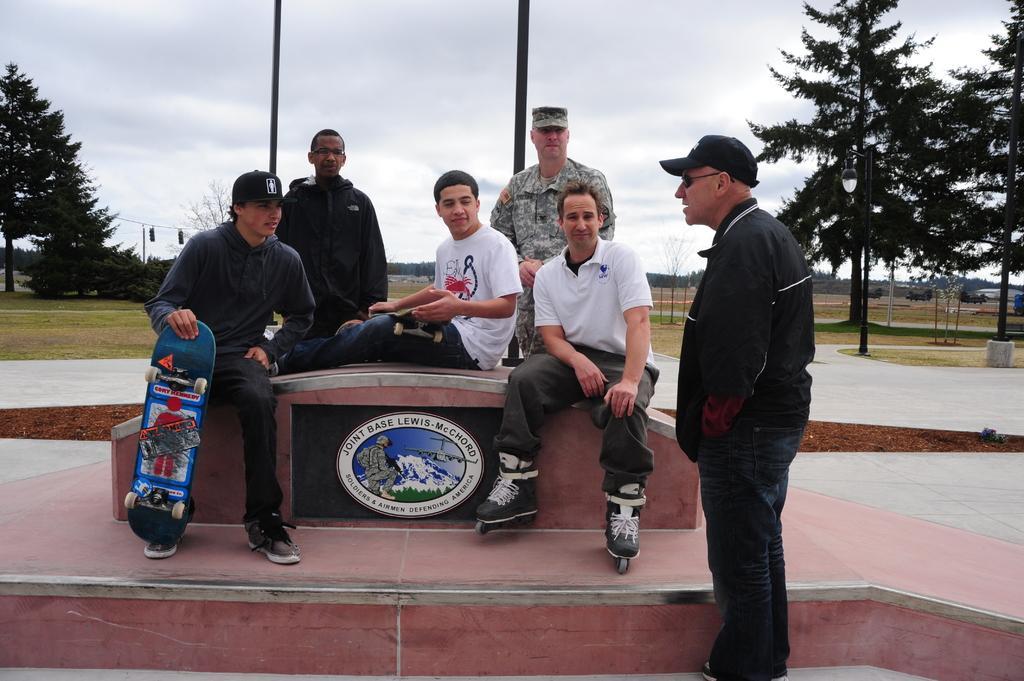In one or two sentences, can you explain what this image depicts? In this picture in the middle, we can see three people sitting on the bench, in that three people, we can see two people are holding a skateboard. On the right side, we can see a man wearing a black color shirt is standing on the land, we can also see some street lights, trees on the right side. On the left side there are some trees, plants, electrical pole. In the background, we can see two men are standing, trees, poles. On the top, we can see a sky which is cloudy, at the bottom, we can also see grass and a land. 